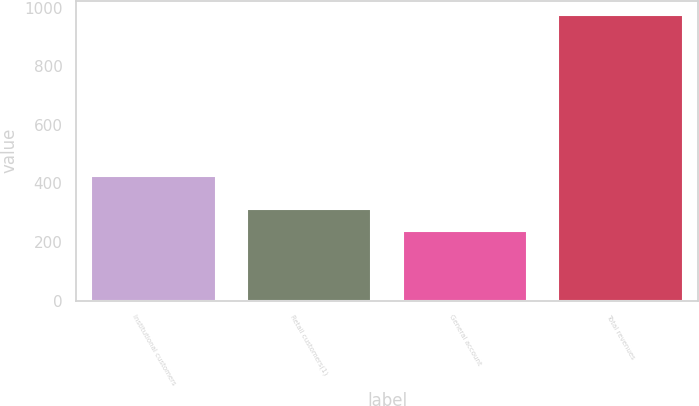<chart> <loc_0><loc_0><loc_500><loc_500><bar_chart><fcel>Institutional customers<fcel>Retail customers(1)<fcel>General account<fcel>Total revenues<nl><fcel>426<fcel>311.6<fcel>238<fcel>974<nl></chart> 